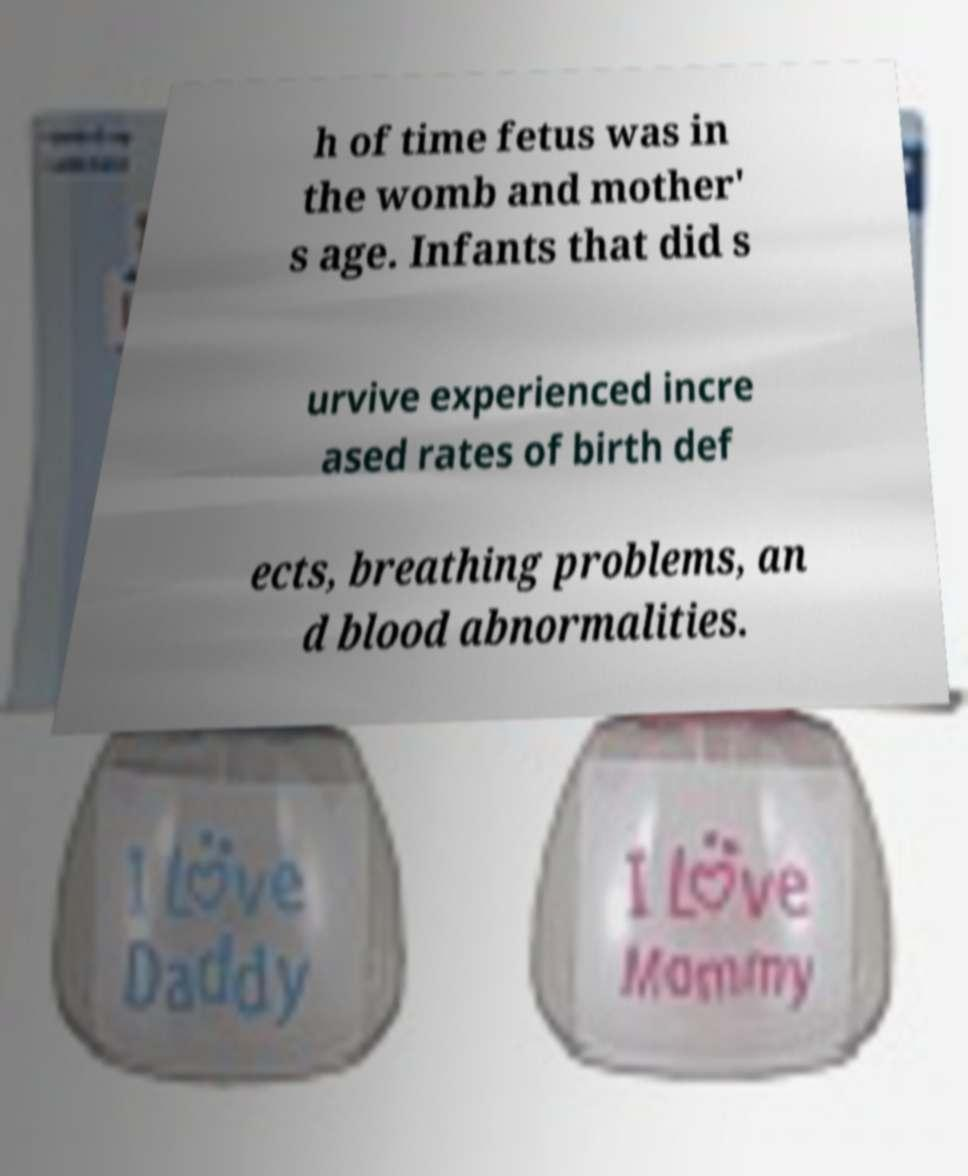There's text embedded in this image that I need extracted. Can you transcribe it verbatim? h of time fetus was in the womb and mother' s age. Infants that did s urvive experienced incre ased rates of birth def ects, breathing problems, an d blood abnormalities. 